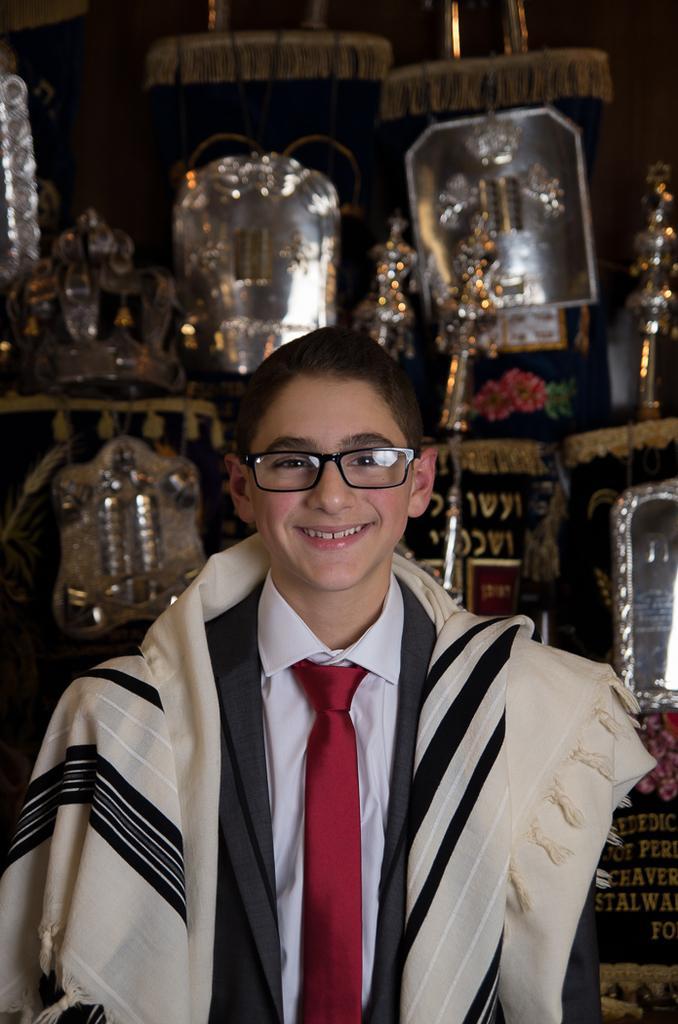Who or what is present in the image? There is a person in the image. Can you describe the person's attire? The person is wearing a dress with black, white, red, and cream colors. What can be seen in the background of the image? There are silver-colored objects in the background of the image. What type of ticket does the person have in their hand in the image? There is no ticket present in the image. Can you describe the carriage that the person is riding in the image? There is no carriage present in the image. 